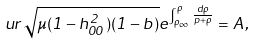<formula> <loc_0><loc_0><loc_500><loc_500>u r \sqrt { \mu ( 1 - h ^ { 2 } _ { 0 0 } ) ( 1 - b ) } e ^ { \int _ { \rho _ { \infty } } ^ { \rho } \frac { d \rho } { p + \rho } } = A ,</formula> 